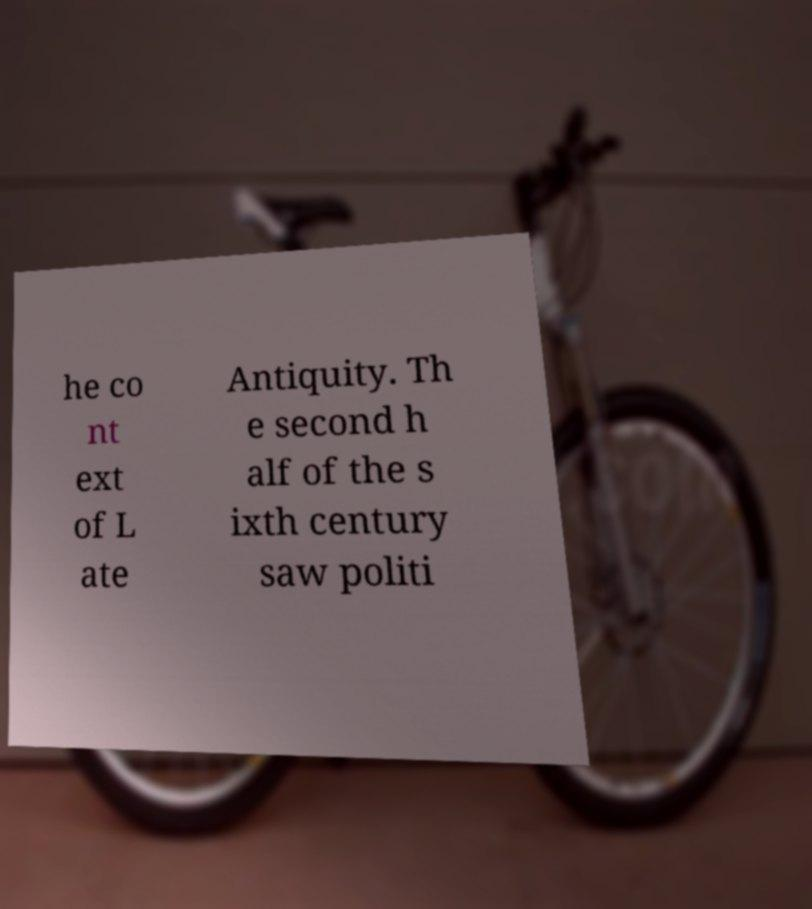Could you extract and type out the text from this image? he co nt ext of L ate Antiquity. Th e second h alf of the s ixth century saw politi 